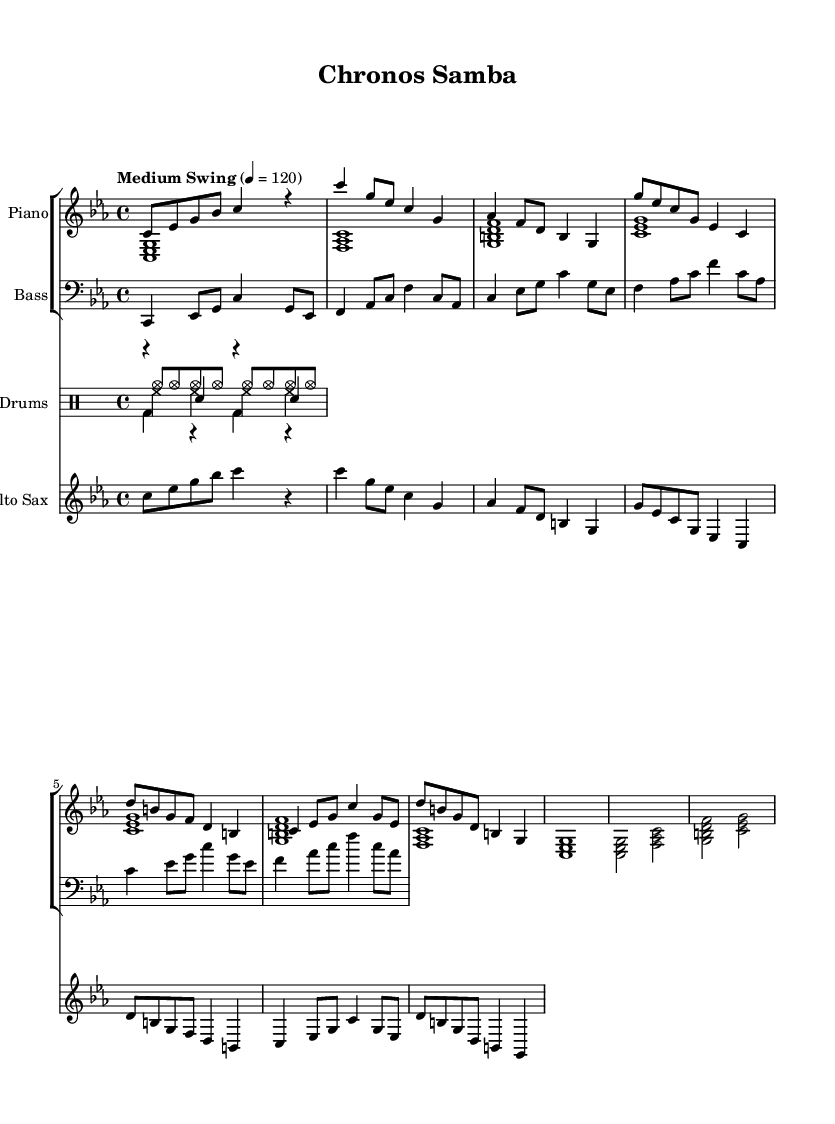What is the key signature of this music? The key signature indicates C minor, which has three flats (B, E, A). This can be determined by identifying the flats in the key signature section of the sheet music.
Answer: C minor What is the time signature of this composition? The time signature shows a 4/4 pattern, which means each measure contains four beats, and the quarter note gets one beat. This is represented at the beginning of the score in the time signature section.
Answer: 4/4 What is the tempo marking for this piece? The tempo marking indicates "Medium Swing" at 120 beats per minute. This is written above the staff, specifying both the style and speed of the performance.
Answer: Medium Swing In which section does the music flow in reverse? The music flows in reverse during the B section, where the notes are structured in a backward motion from G to C and includes descending sequences. This can be identified by observing the musical notes in that section.
Answer: B Section How many measures are in the A section? The A section consists of 4 measures. Each measure can be counted individually in the score, distinguishing between the introductory part and the A section that follows.
Answer: 4 Which instruments are featured in this composition? The composition features Piano, Bass, Drums, and Alto Saxophone, as indicated by the different staves outlined in the score. This can be visually confirmed by looking at the staff groupings at the start.
Answer: Piano, Bass, Drums, Alto Saxophone What notable stylistic element is present in this jazz piece? The composition includes time-bending elements, specifically the backward flow of the B section, which is a hallmark of jazz improvisation and creative expression, showing a unique arrangement not typical in classical music. This element can be identified from the structure of the sections in the score.
Answer: Backward flow 